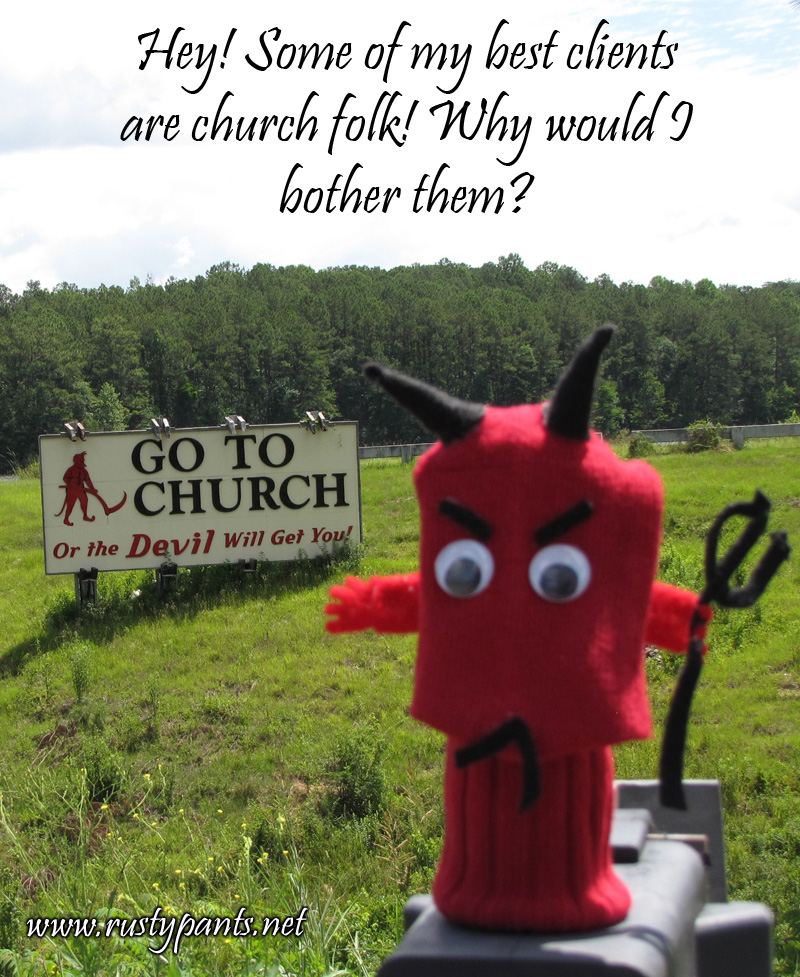What time of day does the lighting in the photograph suggest the picture was taken? The lighting in the photograph suggests that the picture was taken during the day. The presence of shadows under the sign and the bright, diffuse lighting on the scene indicates that it is likely midday or early afternoon, as the sunlight seems to be coming from a high angle, typical of post-noon hours. There are no long shadows that would suggest early morning or late afternoon, and the brightness of the sky supports the deduction of a daytime shot. 